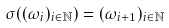Convert formula to latex. <formula><loc_0><loc_0><loc_500><loc_500>\sigma ( ( \omega _ { i } ) _ { i \in \mathbb { N } } ) = ( \omega _ { i + 1 } ) _ { i \in \mathbb { N } }</formula> 